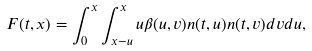<formula> <loc_0><loc_0><loc_500><loc_500>F ( t , x ) = \int _ { 0 } ^ { x } \int _ { x - u } ^ { x } u \beta ( u , v ) n ( t , u ) n ( t , v ) d v d u ,</formula> 